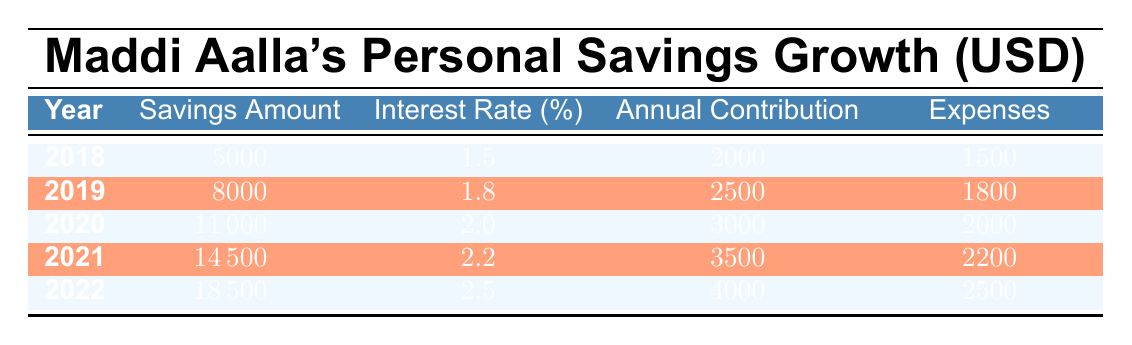What was Maddi's savings amount in 2020? According to the table, the savings amount for the year 2020 is specifically listed as 11000 USD.
Answer: 11000 What was the average interest rate over the five years? To calculate the average interest rate, sum the interest rates (1.5 + 1.8 + 2.0 + 2.2 + 2.5 = 10.0) and divide by the number of years (5). Therefore, the average interest rate is 10.0 / 5 = 2.0%.
Answer: 2.0% Did Maddi's expenses ever exceed her annual contributions? By reviewing the expenses and annual contributions in the table, we see that in 2018 (1500 vs. 2000), 2019 (1800 vs. 2500), 2020 (2000 vs. 3000), 2021 (2200 vs. 3500), and 2022 (2500 vs. 4000), expenses never exceed contributions.
Answer: No What was the total amount Maddi contributed to her savings from 2018 to 2022? To find the total contributions, sum the annual contributions for each year: (2000 + 2500 + 3000 + 3500 + 4000 = 15000). Thus, Maddi contributed a total of 15000 USD over five years.
Answer: 15000 In which year did Maddi have the highest savings growth in terms of annual contributions? Reviewing the annual contributions in each year, we see that the highest contribution was 4000 in 2022. Thus, 2022 saw the highest savings growth from contributions.
Answer: 2022 What was Maddi's savings amount by the end of 2021? The table shows the savings amount for the year 2021 as 14500 USD. Therefore, this is the amount Maddi had saved by the end of 2021.
Answer: 14500 Was there a year where Maddi's savings amount increased by more than 3000 compared to the previous year? Comparing each year's savings amounts, the increase from 2018 to 2019 is 3000 (8000 - 5000), from 2019 to 2020 is 3000 (11000 - 8000), and from 2020 to 2021 is 3500 (14500 - 11000). Therefore, the increment exceeding 3000 occurred from 2020 to 2021.
Answer: Yes What was the total expenses Maddi incurred from 2018 to 2022? To find the total expenses, we sum the expenses for each year: (1500 + 1800 + 2000 + 2200 + 2500 = 11000). Thus, the total expenses over the five years amount to 11000 USD.
Answer: 11000 